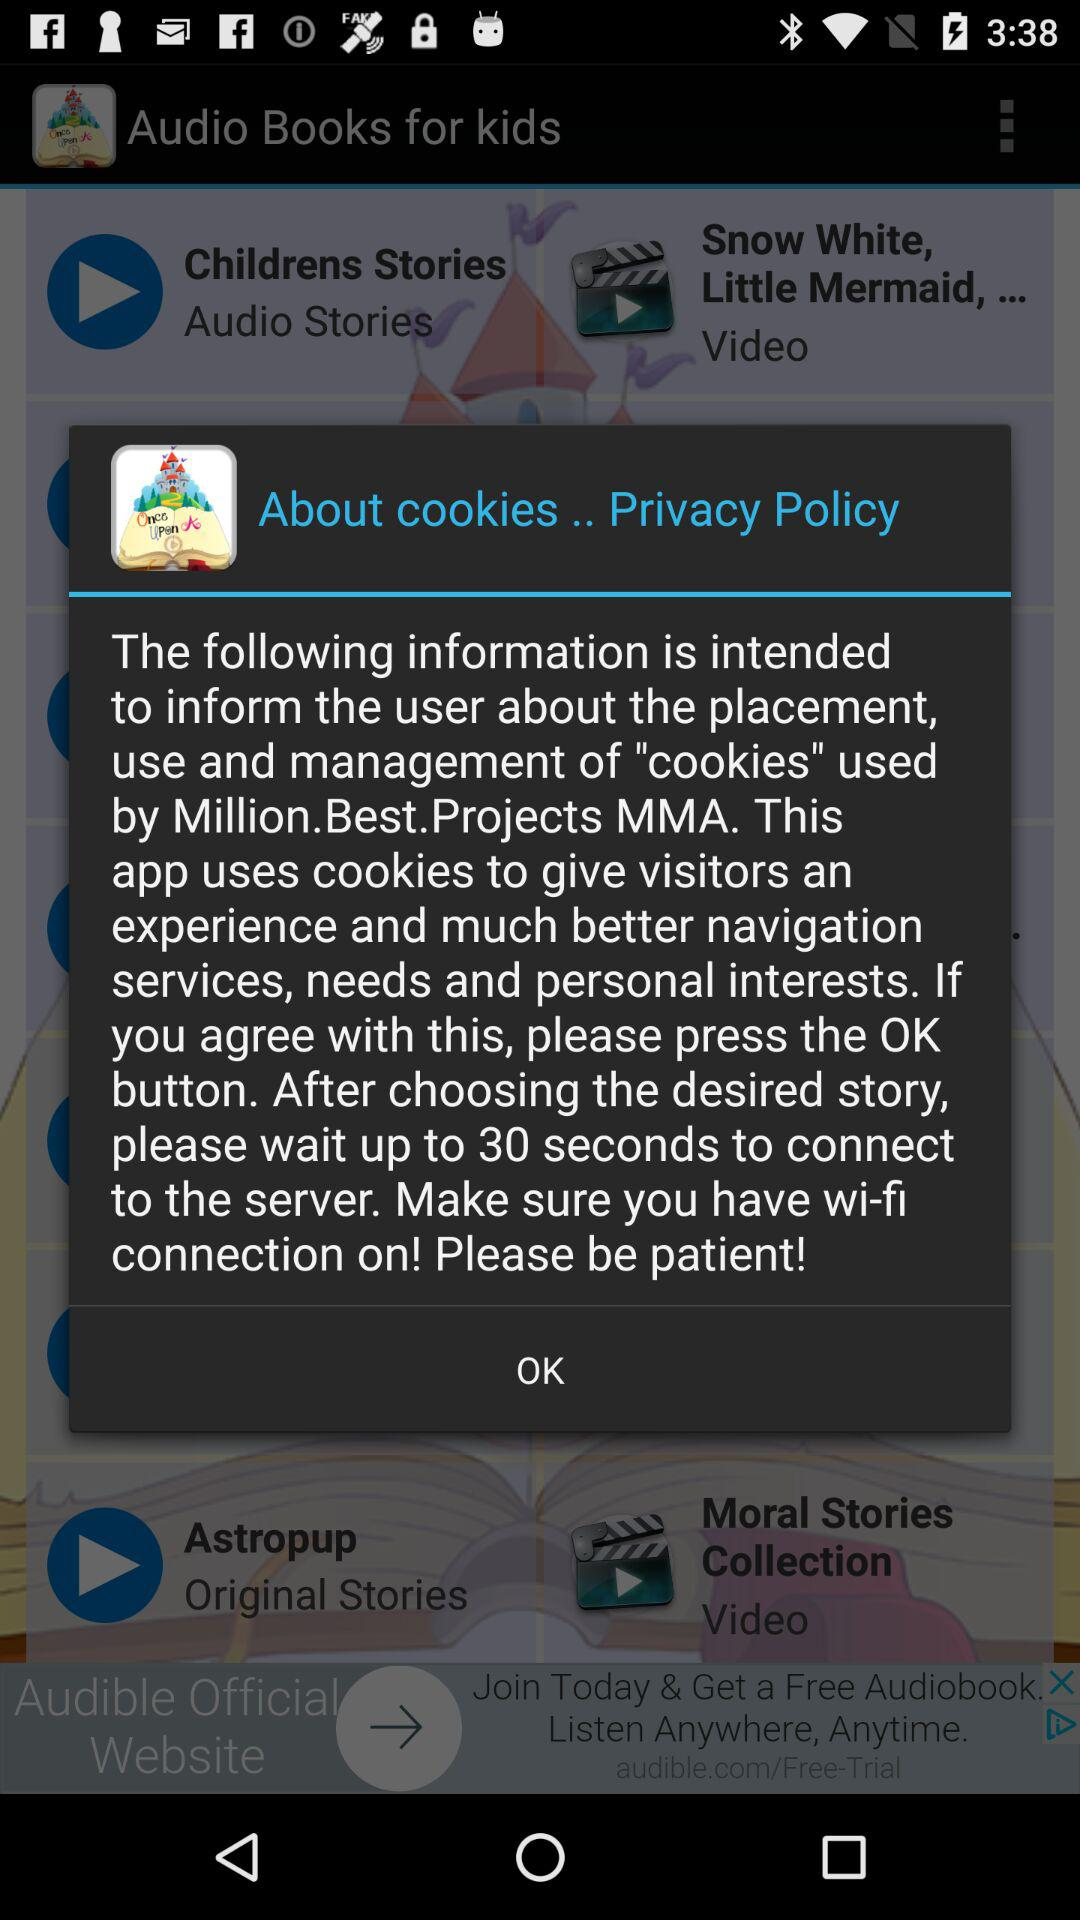How much time will it take to connect to the server after choosing the story? After choosing the story, it will take up to 30 seconds to connect to the server. 